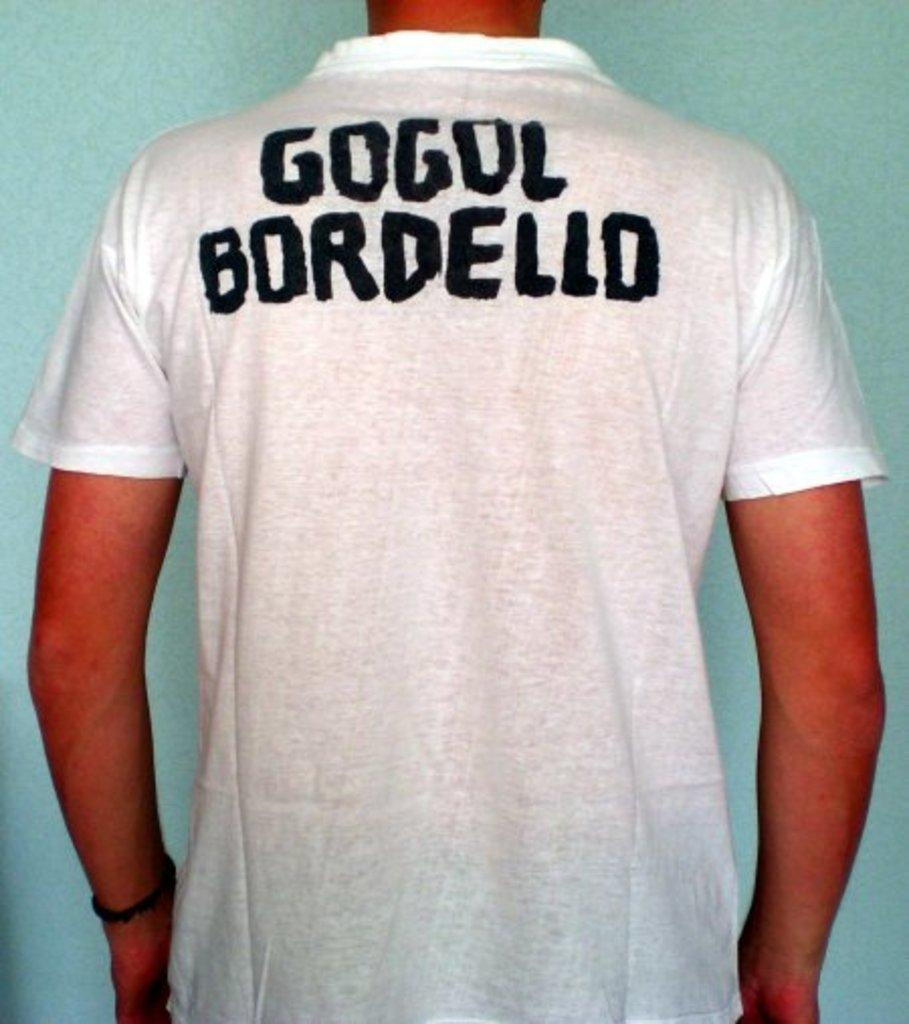Who is present in the image? There is a man in the image. What is the man doing in the image? The man is standing near a wall. What is the man wearing in the image? The man is wearing a white T-shirt. What can be seen on the T-shirt? The T-shirt has some text on it. How many cows are visible in the image? There are no cows present in the image. What type of power source is being used by the man in the image? The image does not provide any information about a power source being used by the man. 